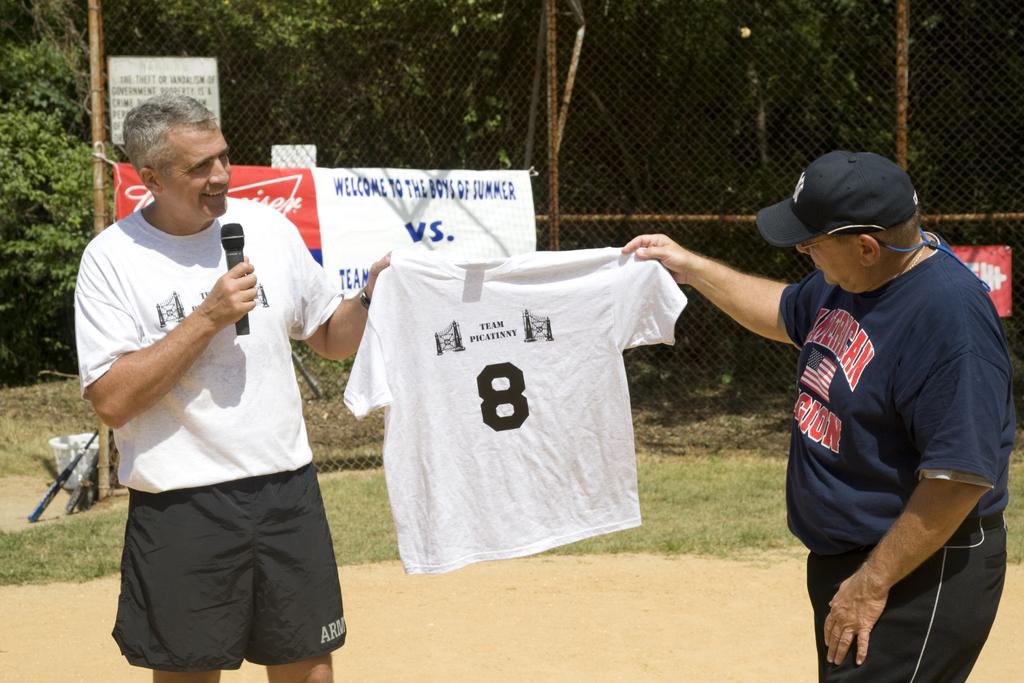What beer brand is on the sign in the background?
Your answer should be very brief. Unanswerable. 